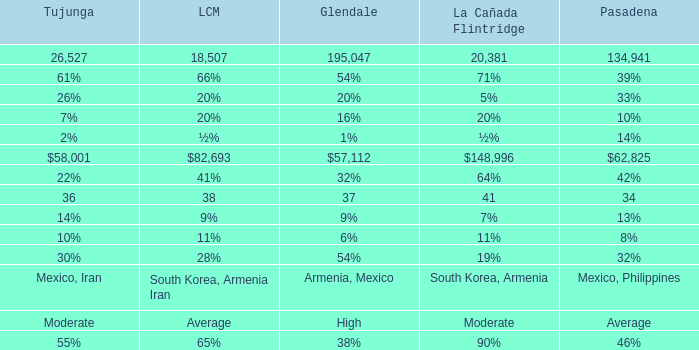What is the percentage of Glendale when La Canada Flintridge is 5%? 20%. 